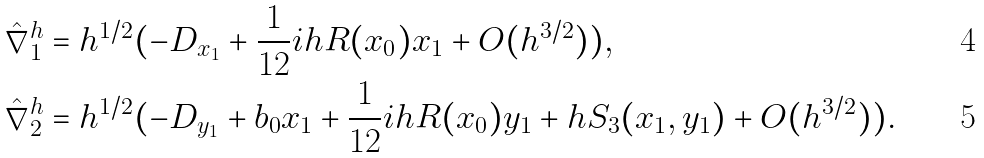<formula> <loc_0><loc_0><loc_500><loc_500>\hat { \nabla } ^ { h } _ { 1 } & = h ^ { 1 / 2 } ( - D _ { x _ { 1 } } + \frac { 1 } { 1 2 } i h R ( x _ { 0 } ) x _ { 1 } + O ( h ^ { 3 / 2 } ) ) , \\ \hat { \nabla } ^ { h } _ { 2 } & = h ^ { 1 / 2 } ( - D _ { y _ { 1 } } + b _ { 0 } x _ { 1 } + \frac { 1 } { 1 2 } i h R ( x _ { 0 } ) y _ { 1 } + h S _ { 3 } ( x _ { 1 } , y _ { 1 } ) + O ( h ^ { 3 / 2 } ) ) .</formula> 